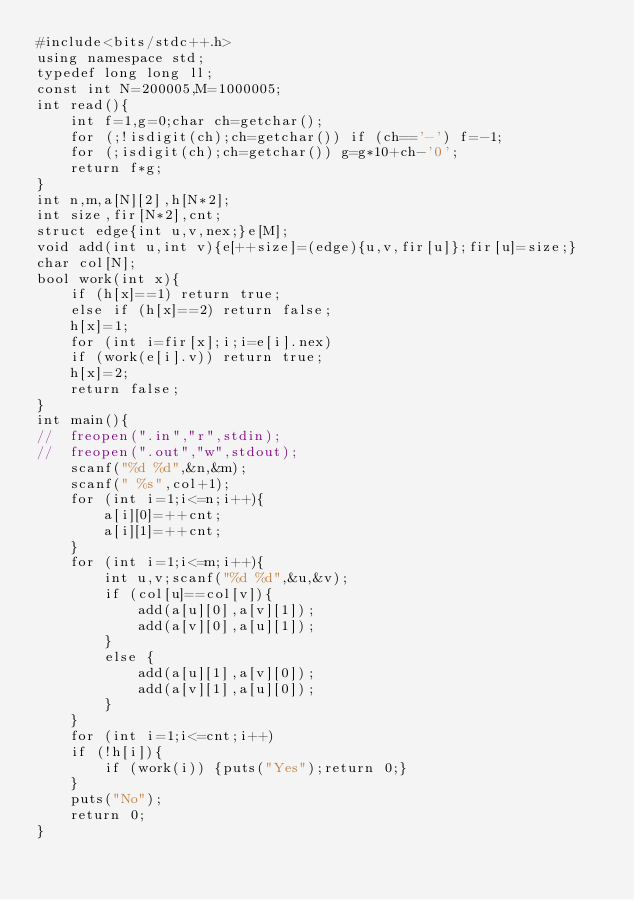Convert code to text. <code><loc_0><loc_0><loc_500><loc_500><_C++_>#include<bits/stdc++.h>
using namespace std;
typedef long long ll;
const int N=200005,M=1000005;
int read(){
	int f=1,g=0;char ch=getchar();
	for (;!isdigit(ch);ch=getchar()) if (ch=='-') f=-1;
	for (;isdigit(ch);ch=getchar()) g=g*10+ch-'0';
	return f*g;
}
int n,m,a[N][2],h[N*2];
int size,fir[N*2],cnt;
struct edge{int u,v,nex;}e[M];
void add(int u,int v){e[++size]=(edge){u,v,fir[u]};fir[u]=size;}
char col[N];
bool work(int x){
	if (h[x]==1) return true;
	else if (h[x]==2) return false;
	h[x]=1;
	for (int i=fir[x];i;i=e[i].nex)
	if (work(e[i].v)) return true;
	h[x]=2;
	return false;
}
int main(){
//	freopen(".in","r",stdin);
//	freopen(".out","w",stdout);
	scanf("%d %d",&n,&m);
	scanf(" %s",col+1);
	for (int i=1;i<=n;i++){
		a[i][0]=++cnt;
		a[i][1]=++cnt;
	}
	for (int i=1;i<=m;i++){
		int u,v;scanf("%d %d",&u,&v);
		if (col[u]==col[v]){
			add(a[u][0],a[v][1]);
			add(a[v][0],a[u][1]);
		}
		else {
			add(a[u][1],a[v][0]);
			add(a[v][1],a[u][0]);
		}
	}
	for (int i=1;i<=cnt;i++)
	if (!h[i]){
		if (work(i)) {puts("Yes");return 0;}
	}
	puts("No");
	return 0;
}</code> 